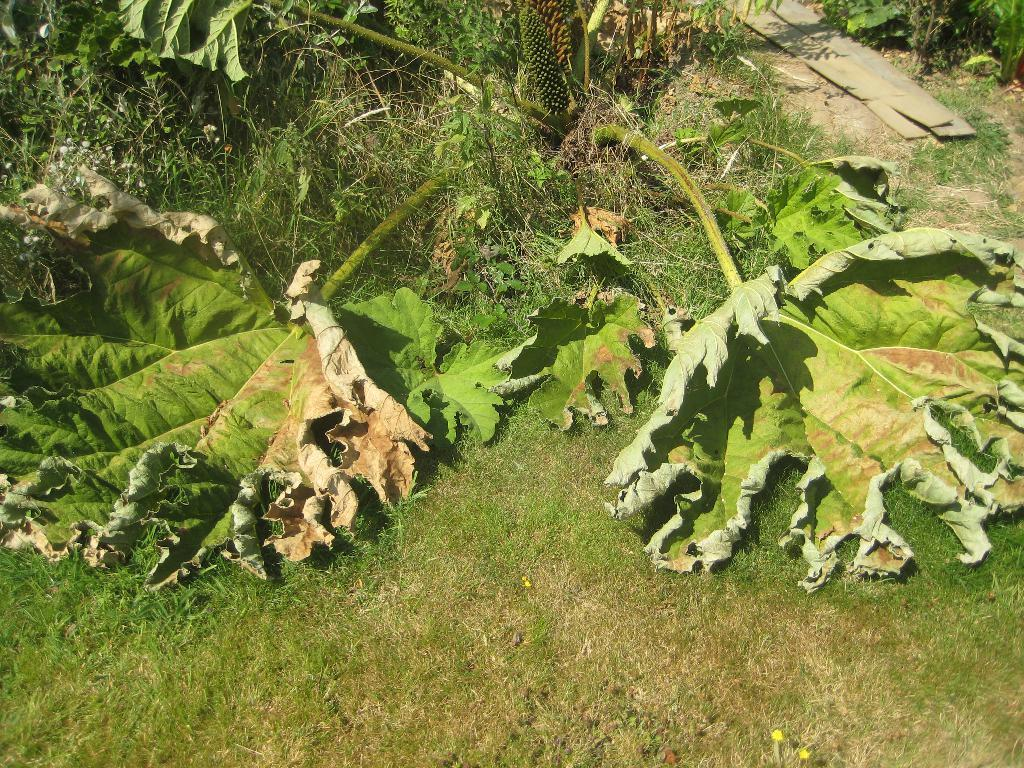What type of vegetation is present in the image? There are plants in the image. What is covering the ground in the image? There is grass on the ground in the image. What type of cup can be seen in the image? There is no cup present in the image. Is there a toothbrush visible in the image? There is no toothbrush present in the image. 